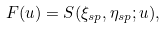<formula> <loc_0><loc_0><loc_500><loc_500>F ( u ) = S ( \xi _ { s p } , \eta _ { s p } ; u ) ,</formula> 